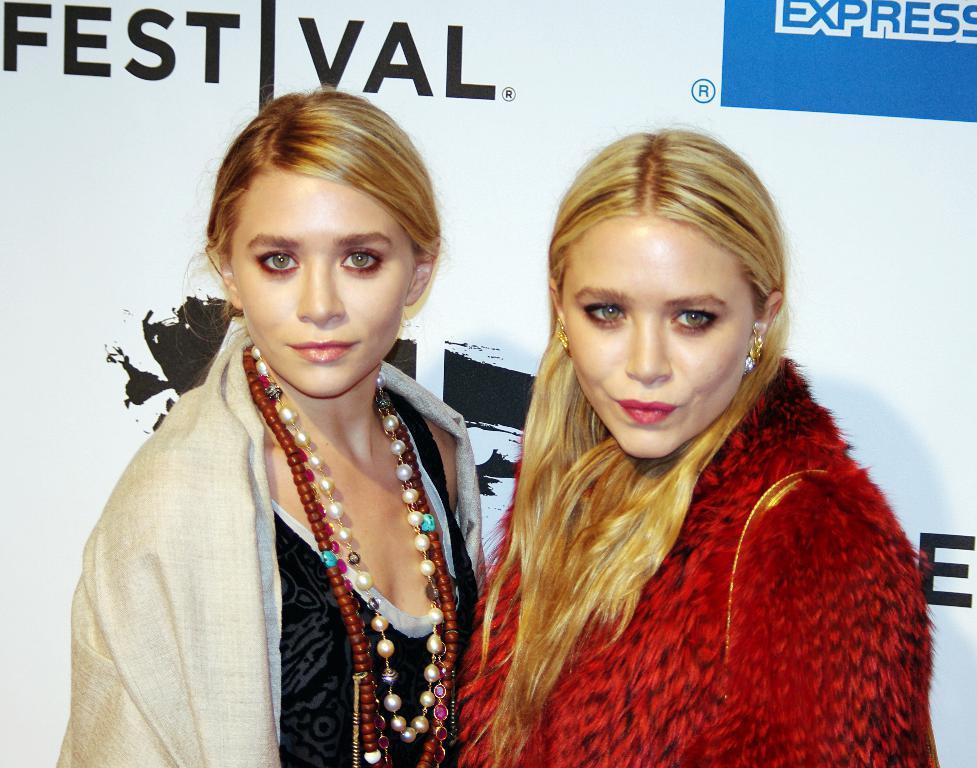Describe this image in one or two sentences. In this image there are two women standing, behind them there is a banner with some images and text on it. 